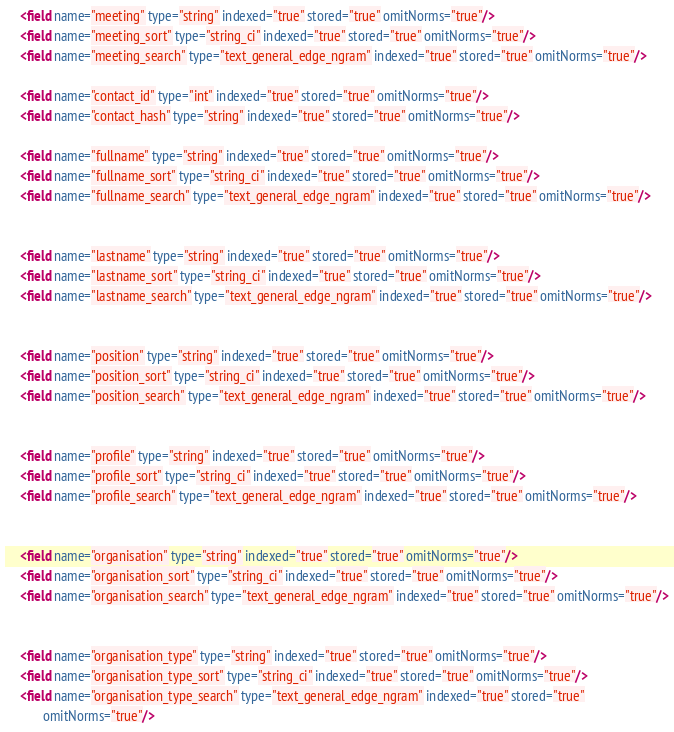Convert code to text. <code><loc_0><loc_0><loc_500><loc_500><_XML_>
    <field name="meeting" type="string" indexed="true" stored="true" omitNorms="true"/>
    <field name="meeting_sort" type="string_ci" indexed="true" stored="true" omitNorms="true"/>
    <field name="meeting_search" type="text_general_edge_ngram" indexed="true" stored="true" omitNorms="true"/>

    <field name="contact_id" type="int" indexed="true" stored="true" omitNorms="true"/>
    <field name="contact_hash" type="string" indexed="true" stored="true" omitNorms="true"/>

    <field name="fullname" type="string" indexed="true" stored="true" omitNorms="true"/>
    <field name="fullname_sort" type="string_ci" indexed="true" stored="true" omitNorms="true"/>
    <field name="fullname_search" type="text_general_edge_ngram" indexed="true" stored="true" omitNorms="true"/>


    <field name="lastname" type="string" indexed="true" stored="true" omitNorms="true"/>
    <field name="lastname_sort" type="string_ci" indexed="true" stored="true" omitNorms="true"/>
    <field name="lastname_search" type="text_general_edge_ngram" indexed="true" stored="true" omitNorms="true"/>


    <field name="position" type="string" indexed="true" stored="true" omitNorms="true"/>
    <field name="position_sort" type="string_ci" indexed="true" stored="true" omitNorms="true"/>
    <field name="position_search" type="text_general_edge_ngram" indexed="true" stored="true" omitNorms="true"/>


    <field name="profile" type="string" indexed="true" stored="true" omitNorms="true"/>
    <field name="profile_sort" type="string_ci" indexed="true" stored="true" omitNorms="true"/>
    <field name="profile_search" type="text_general_edge_ngram" indexed="true" stored="true" omitNorms="true"/>


    <field name="organisation" type="string" indexed="true" stored="true" omitNorms="true"/>
    <field name="organisation_sort" type="string_ci" indexed="true" stored="true" omitNorms="true"/>
    <field name="organisation_search" type="text_general_edge_ngram" indexed="true" stored="true" omitNorms="true"/>


    <field name="organisation_type" type="string" indexed="true" stored="true" omitNorms="true"/>
    <field name="organisation_type_sort" type="string_ci" indexed="true" stored="true" omitNorms="true"/>
    <field name="organisation_type_search" type="text_general_edge_ngram" indexed="true" stored="true"
           omitNorms="true"/>
</code> 